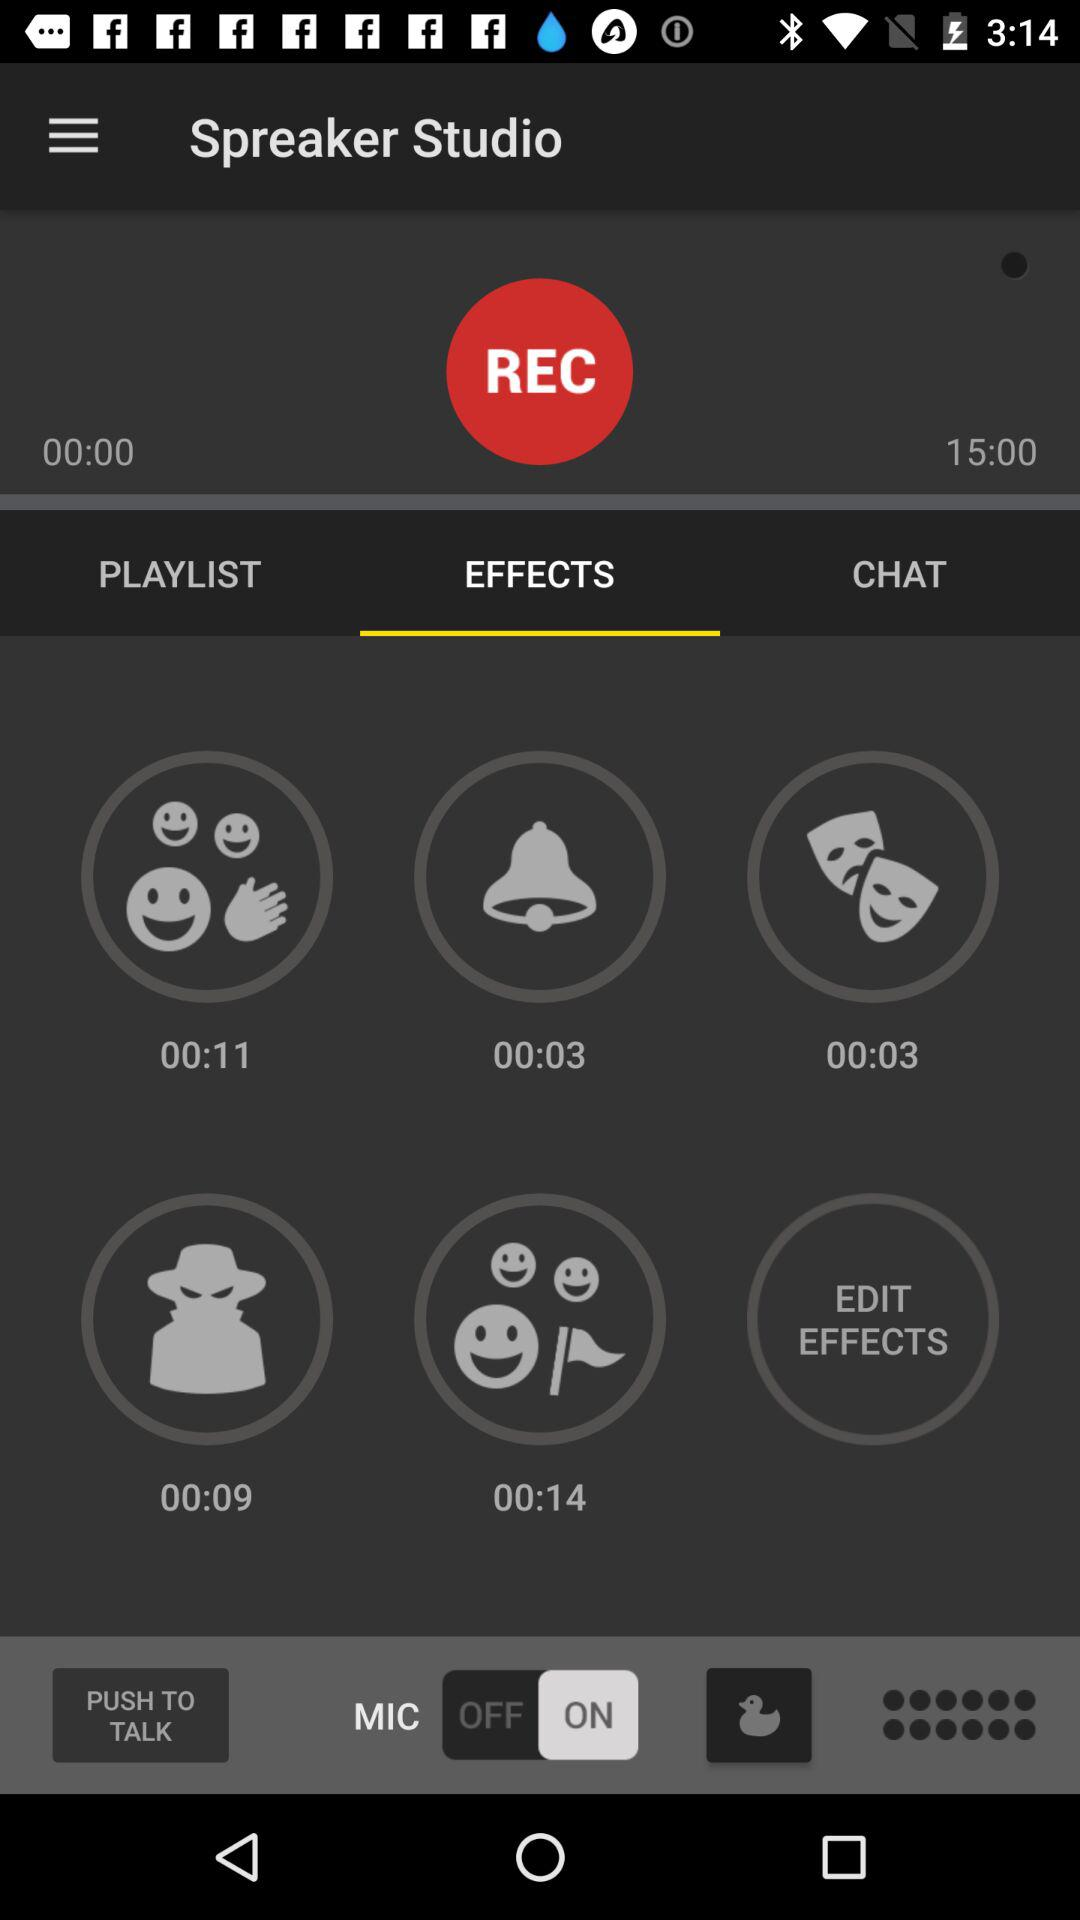What is the status of "MIC"? The status of "MIC" is "on". 